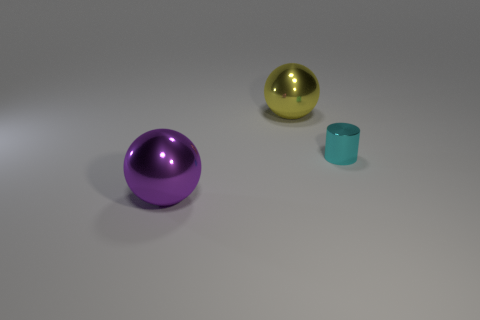There is a shiny object that is on the left side of the cylinder and in front of the large yellow ball; what size is it?
Offer a terse response. Large. What is the shape of the tiny cyan metal thing?
Provide a short and direct response. Cylinder. Is there a yellow shiny sphere that is right of the big metallic thing that is right of the purple object?
Your answer should be very brief. No. What number of small things are behind the big ball on the left side of the large yellow shiny thing?
Offer a terse response. 1. What material is the yellow sphere that is the same size as the purple metal sphere?
Provide a succinct answer. Metal. There is a large object to the right of the large purple object; is it the same shape as the tiny cyan thing?
Provide a short and direct response. No. Are there more metal things left of the big purple metal ball than spheres that are to the left of the big yellow metallic thing?
Make the answer very short. No. How many other tiny cyan objects have the same material as the small thing?
Offer a very short reply. 0. Is the cyan cylinder the same size as the purple metallic object?
Keep it short and to the point. No. What color is the metallic cylinder?
Offer a very short reply. Cyan. 